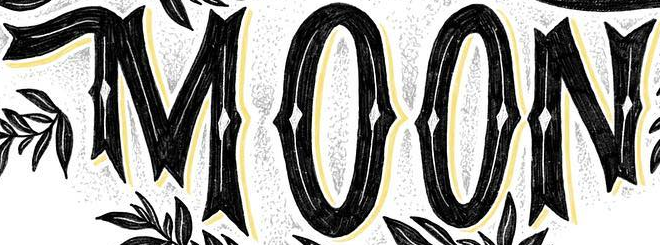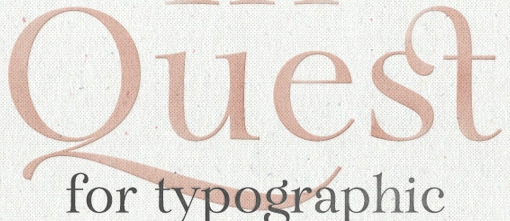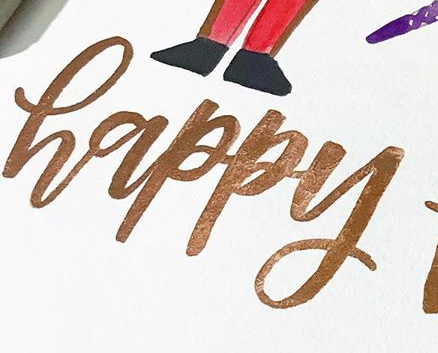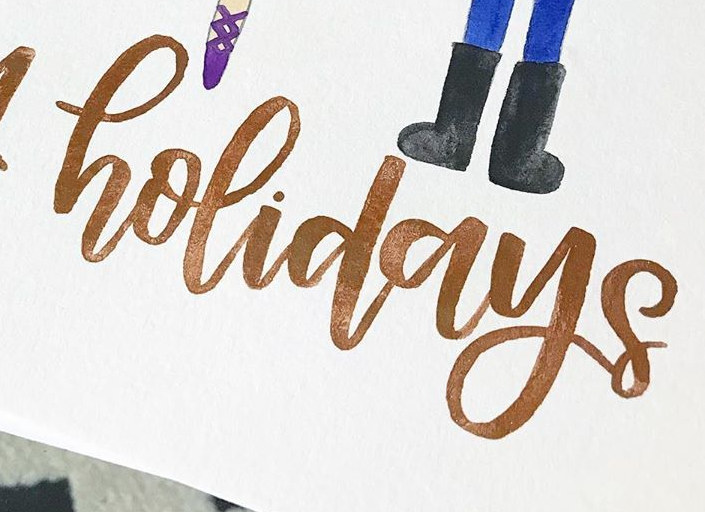What text is displayed in these images sequentially, separated by a semicolon? MOON; Quest; happy; holidays 